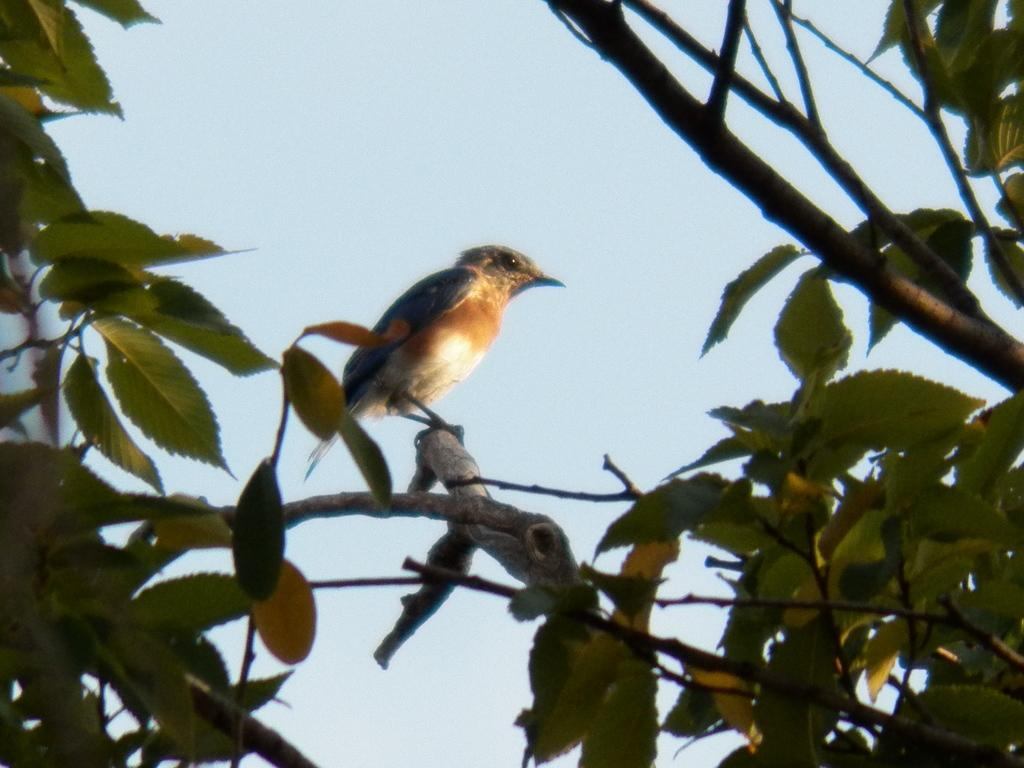What type of animal can be seen in the image? There is a bird in the image. Where is the bird located? The bird is on the stem of a tree. What can be seen in the background of the image? There is sky visible in the background of the image. What type of basin is the bird using to take a bath in the image? There is no basin present in the image, and the bird is not taking a bath. 